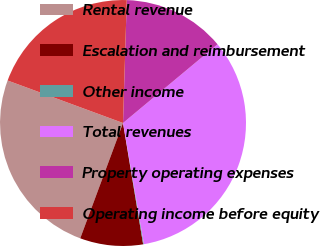Convert chart. <chart><loc_0><loc_0><loc_500><loc_500><pie_chart><fcel>Rental revenue<fcel>Escalation and reimbursement<fcel>Other income<fcel>Total revenues<fcel>Property operating expenses<fcel>Operating income before equity<nl><fcel>24.96%<fcel>8.27%<fcel>0.1%<fcel>33.33%<fcel>13.46%<fcel>19.87%<nl></chart> 